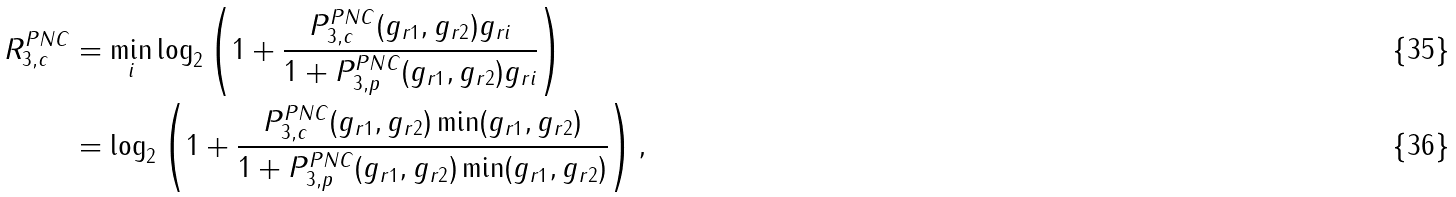<formula> <loc_0><loc_0><loc_500><loc_500>R _ { 3 , c } ^ { P N C } & = \min _ { i } \log _ { 2 } \left ( 1 + \frac { P _ { 3 , c } ^ { P N C } ( g _ { r 1 } , g _ { r 2 } ) g _ { r i } } { 1 + P _ { 3 , p } ^ { P N C } ( g _ { r 1 } , g _ { r 2 } ) g _ { r i } } \right ) \\ & = \log _ { 2 } \left ( 1 + \frac { P _ { 3 , c } ^ { P N C } ( g _ { r 1 } , g _ { r 2 } ) \min ( g _ { r 1 } , g _ { r 2 } ) } { 1 + P _ { 3 , p } ^ { P N C } ( g _ { r 1 } , g _ { r 2 } ) \min ( g _ { r 1 } , g _ { r 2 } ) } \right ) ,</formula> 